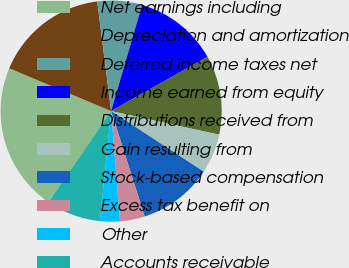Convert chart to OTSL. <chart><loc_0><loc_0><loc_500><loc_500><pie_chart><fcel>Net earnings including<fcel>Depreciation and amortization<fcel>Deferred income taxes net<fcel>Income earned from equity<fcel>Distributions received from<fcel>Gain resulting from<fcel>Stock-based compensation<fcel>Excess tax benefit on<fcel>Other<fcel>Accounts receivable<nl><fcel>21.73%<fcel>16.66%<fcel>6.52%<fcel>12.32%<fcel>11.59%<fcel>5.8%<fcel>10.87%<fcel>3.63%<fcel>2.9%<fcel>7.97%<nl></chart> 